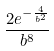<formula> <loc_0><loc_0><loc_500><loc_500>\frac { 2 e ^ { - \frac { 4 } { b ^ { 2 } } } } { b ^ { 8 } }</formula> 